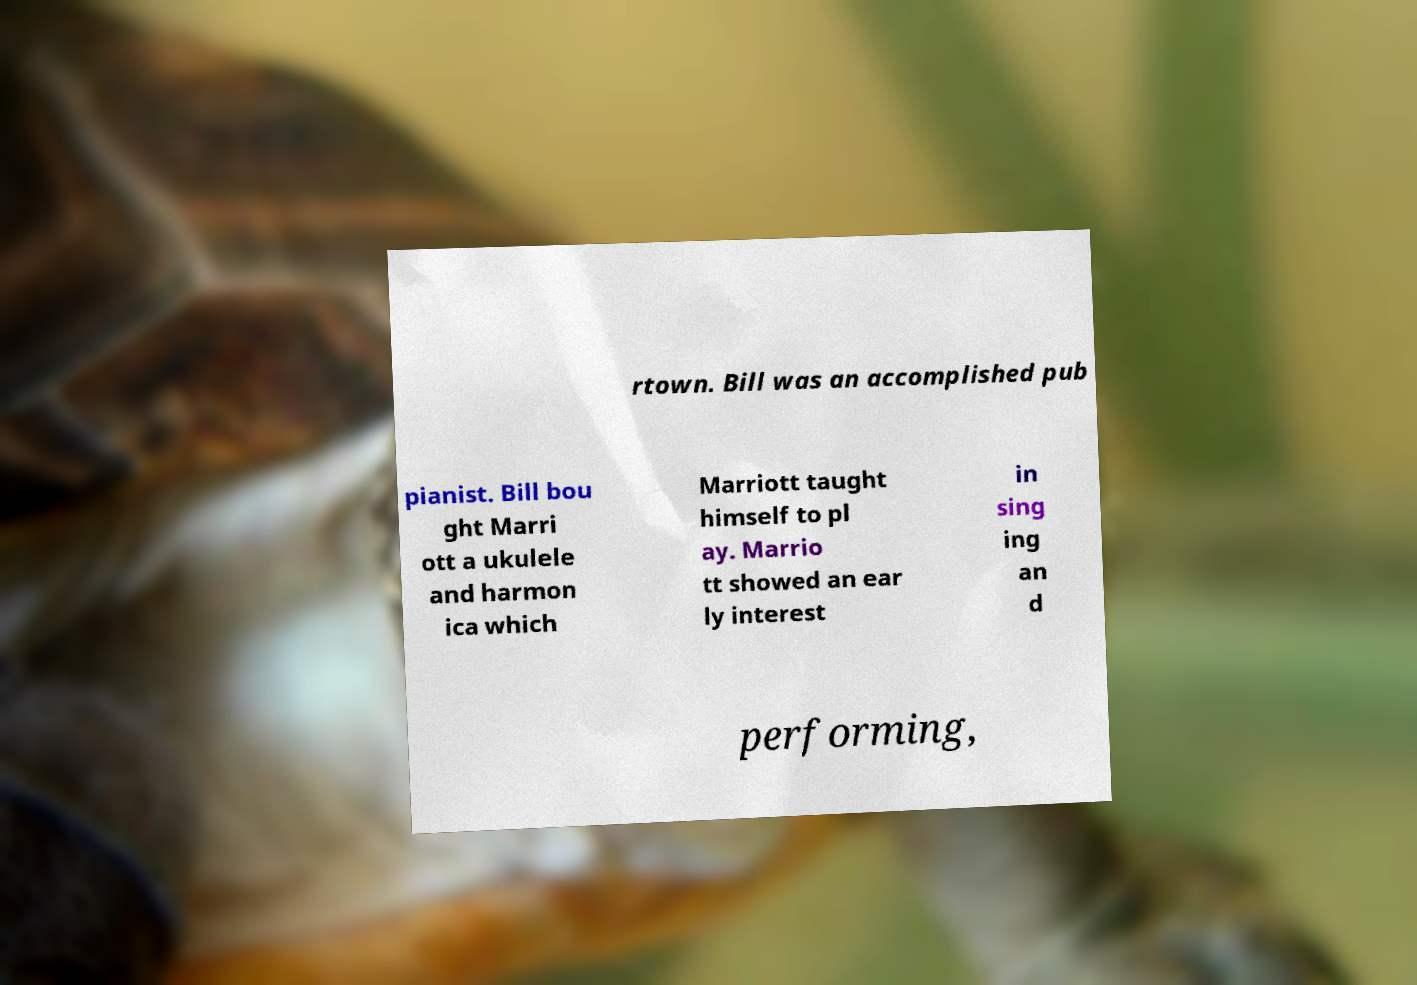Can you accurately transcribe the text from the provided image for me? rtown. Bill was an accomplished pub pianist. Bill bou ght Marri ott a ukulele and harmon ica which Marriott taught himself to pl ay. Marrio tt showed an ear ly interest in sing ing an d performing, 